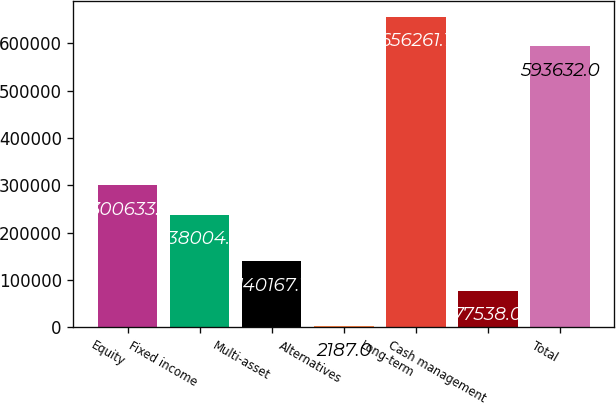Convert chart to OTSL. <chart><loc_0><loc_0><loc_500><loc_500><bar_chart><fcel>Equity<fcel>Fixed income<fcel>Multi-asset<fcel>Alternatives<fcel>Long-term<fcel>Cash management<fcel>Total<nl><fcel>300633<fcel>238004<fcel>140167<fcel>2187<fcel>656261<fcel>77538<fcel>593632<nl></chart> 